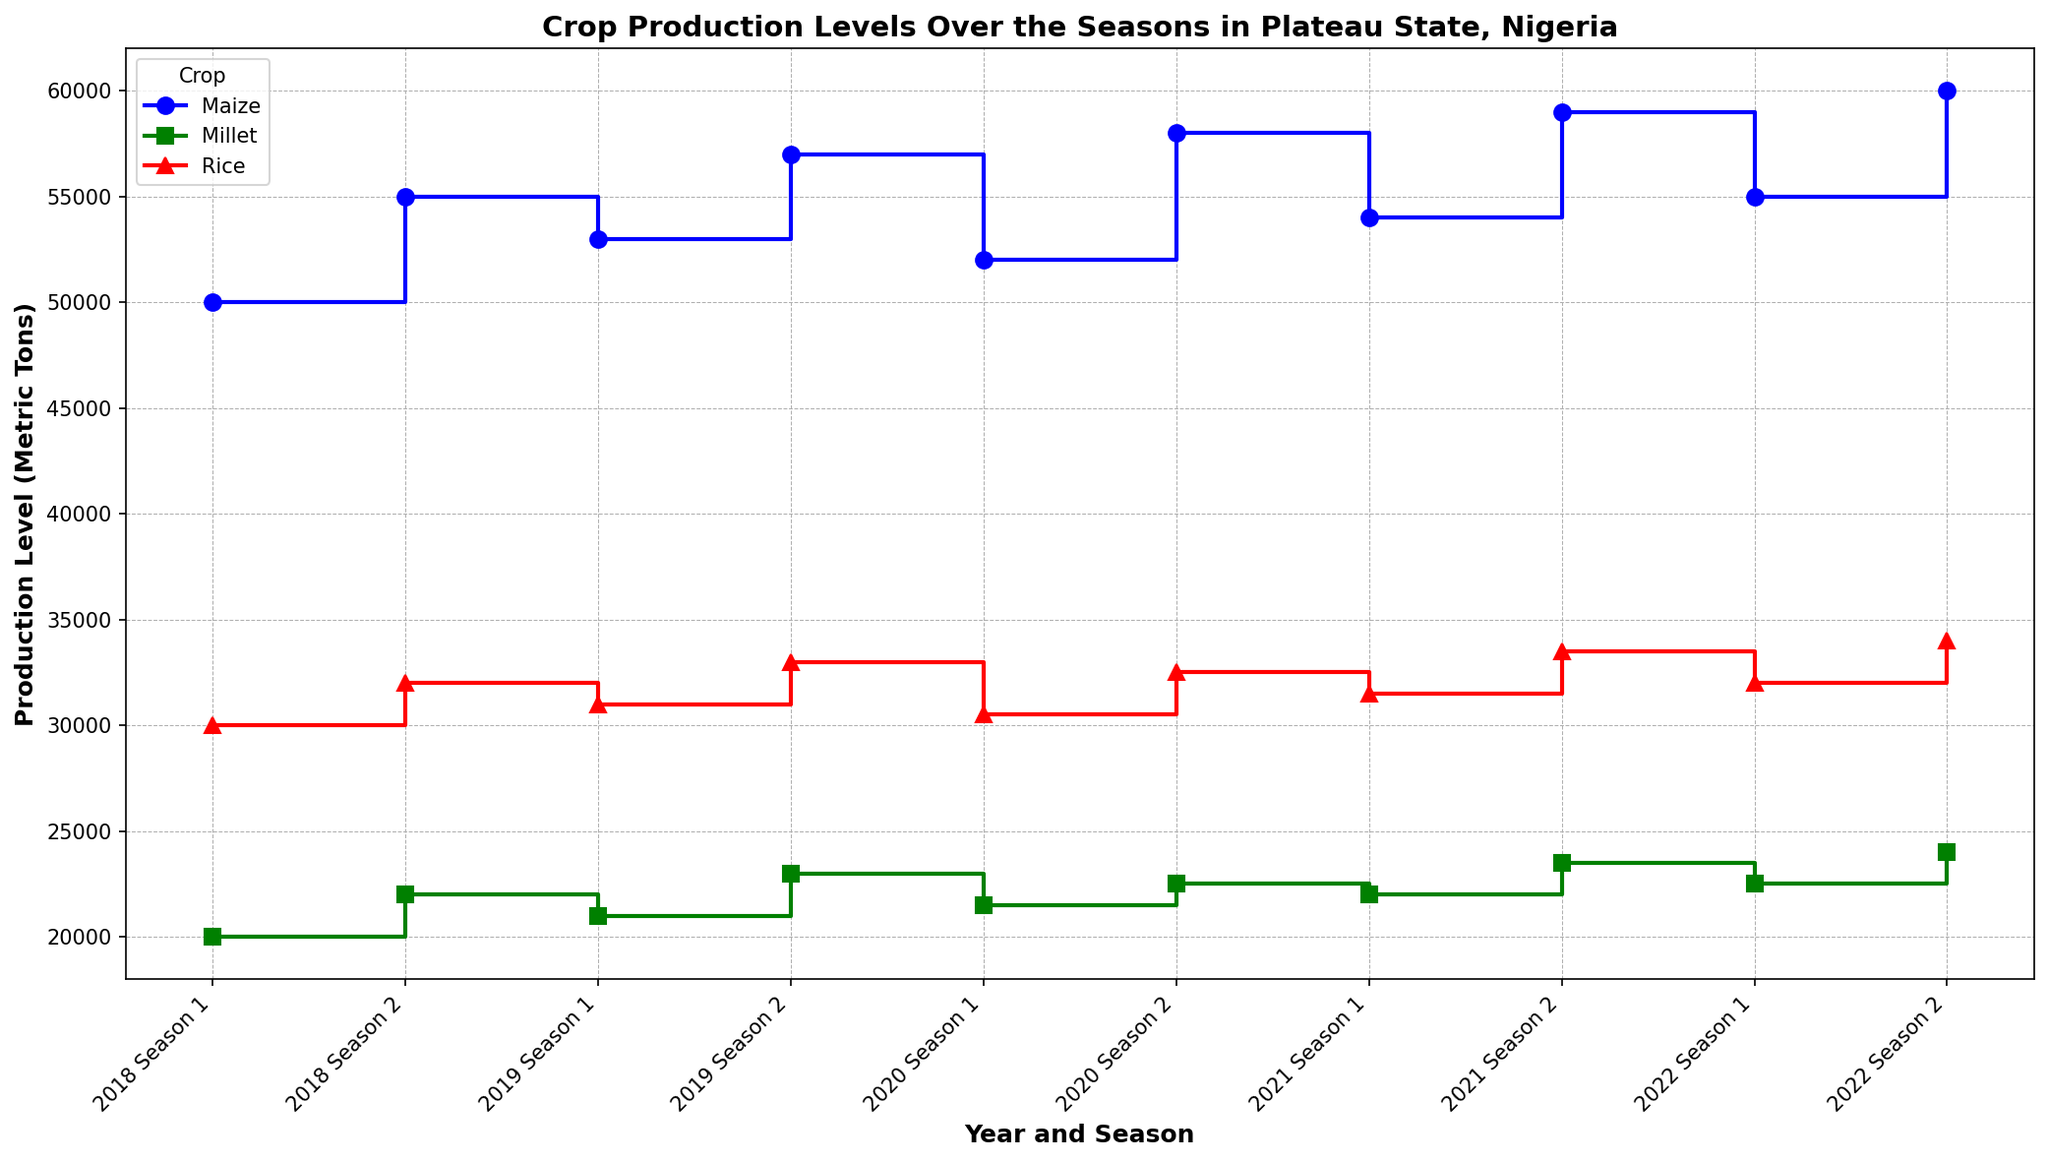What crop showed the highest production level in Season 2 of 2022? Look for the '2022 Season 2' labels on the x-axis and compare the heights of the markers for Maize, Millet, and Rice. The marker for Maize is the highest.
Answer: Maize Which crop's production level increased the most between Season 1 and Season 2 in 2021? Locate the two markers for each crop in 2021 on the x-axis (one in Season 1 and another in Season 2) and compare the differences. Maize's production increased from 54,000 to 59,000.
Answer: Maize Comparing the production levels of Millet in Season 1 over the years, which year had the lowest production level? Trace the markers for Millet in each 'Season 1' across different years and identify the lowest point. It is 2018 with a production level of 20,000 metric tons.
Answer: 2018 In 2020, what was the difference in production levels between Maize in Season 1 and Season 2? Check 2020 on the x-axis, find the markers for Maize in Season 1 (52,000) and Season 2 (58,000), and calculate the difference (58,000 - 52,000).
Answer: 6,000 metric tons What is the average production level of Rice in Season 1 across the years 2018 to 2022? Identify the production levels of Rice in Season 1 for each year: 2018 (30,000), 2019 (31,000), 2020 (30,500), 2021 (31,500), and 2022 (32,000). Sum these values and divide by 5. (30,000 + 31,000 + 30,500 + 31,500 + 32,000)/5 = 31,000.
Answer: 31,000 metric tons Which crop had the smallest range of production levels over the given seasons? Calculate the range (difference between the highest and lowest production levels) for each crop across all seasons. For Maize (60,000 - 50,000), Millet (24,000 - 20,000), and Rice (34,000 - 30,000). Rice has the smallest range (4,000).
Answer: Rice Did any crop maintain the same production levels for two consecutive seasons in consecutive years? Look for consecutive markers with the same heights. None of the crops have the same production levels for two consecutive seasons in consecutive years.
Answer: No Considering all seasons and crops, which year showed the highest overall production level for Maize? Check the highest markers for Maize across all seasons and years. The highest marker for Maize is in 2022 Season 2 with 60,000 metric tons.
Answer: 2022 